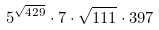<formula> <loc_0><loc_0><loc_500><loc_500>5 ^ { \sqrt { 4 2 9 } } \cdot 7 \cdot \sqrt { 1 1 1 } \cdot 3 9 7</formula> 